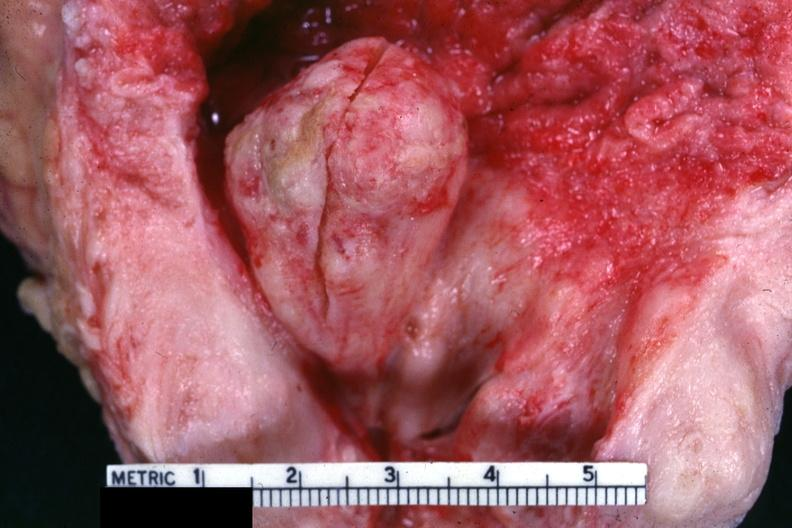does this image show good example of nodule protruding into bladder?
Answer the question using a single word or phrase. Yes 